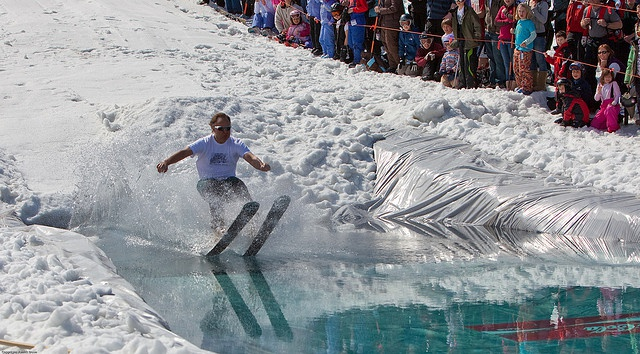Describe the objects in this image and their specific colors. I can see people in lightgray, black, darkgray, and gray tones, people in lightgray, gray, darkgray, and black tones, people in lightgray, black, maroon, and brown tones, skis in lightgray, gray, black, and purple tones, and people in lightgray, black, maroon, gray, and brown tones in this image. 